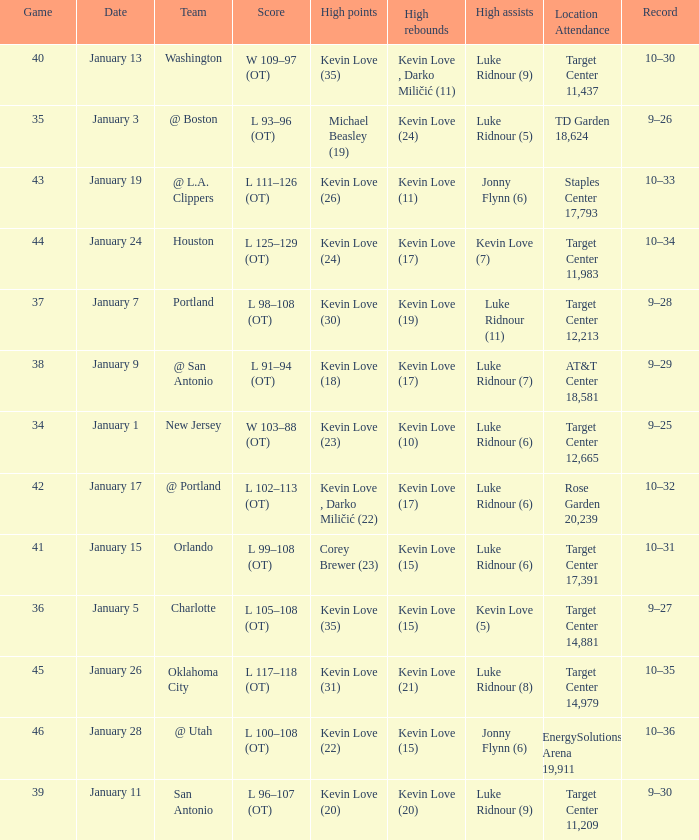What is the date for the game with team orlando? January 15. 